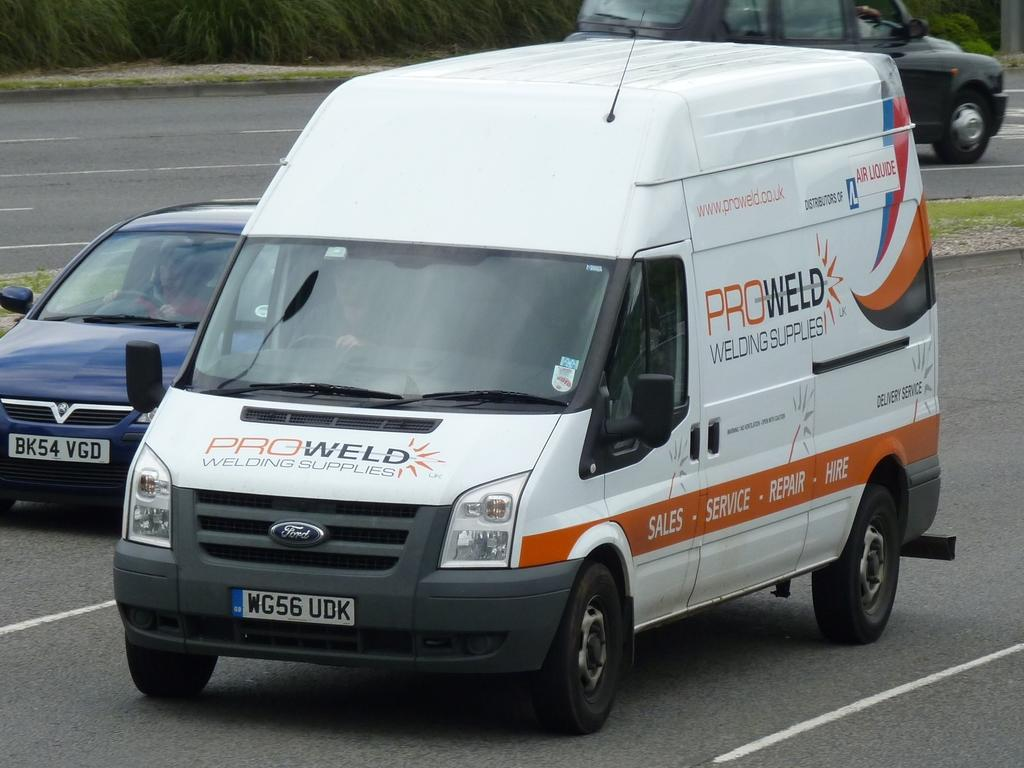<image>
Summarize the visual content of the image. A ProWeld van drives along next to a blue sedan. 